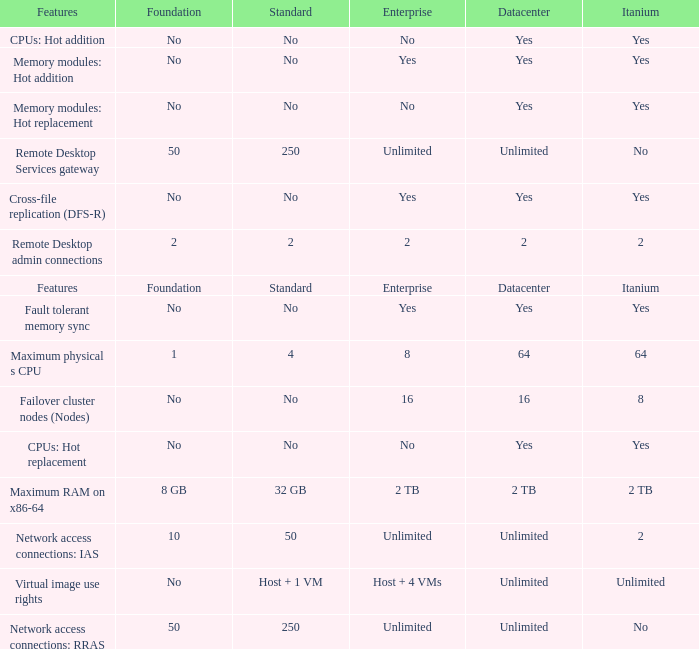What is the Datacenter for the Fault Tolerant Memory Sync Feature that has Yes for Itanium and No for Standard? Yes. 